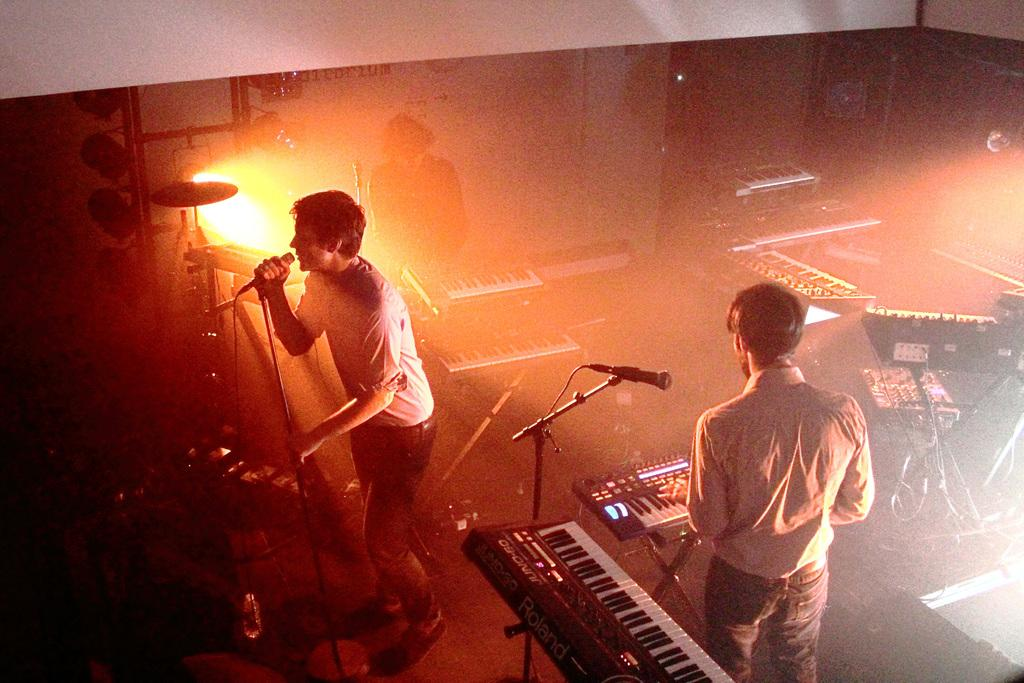What is the man in the image doing? The man is singing in the image. What is the man holding while singing? The man is holding a microphone. Can you describe the other person in the image? There is a man playing the piano in the image. Where is the piano located in relation to the other elements in the image? The piano is on the right side of the image. What can be seen in the background of the image? There is light visible in the background of the image. How many hooks are hanging on the wall behind the piano in the image? There are no hooks visible in the image; it only features the two men and their respective instruments. What type of houses can be seen in the background of the image? There are no houses present in the image; it only features the two men and their respective instruments. 